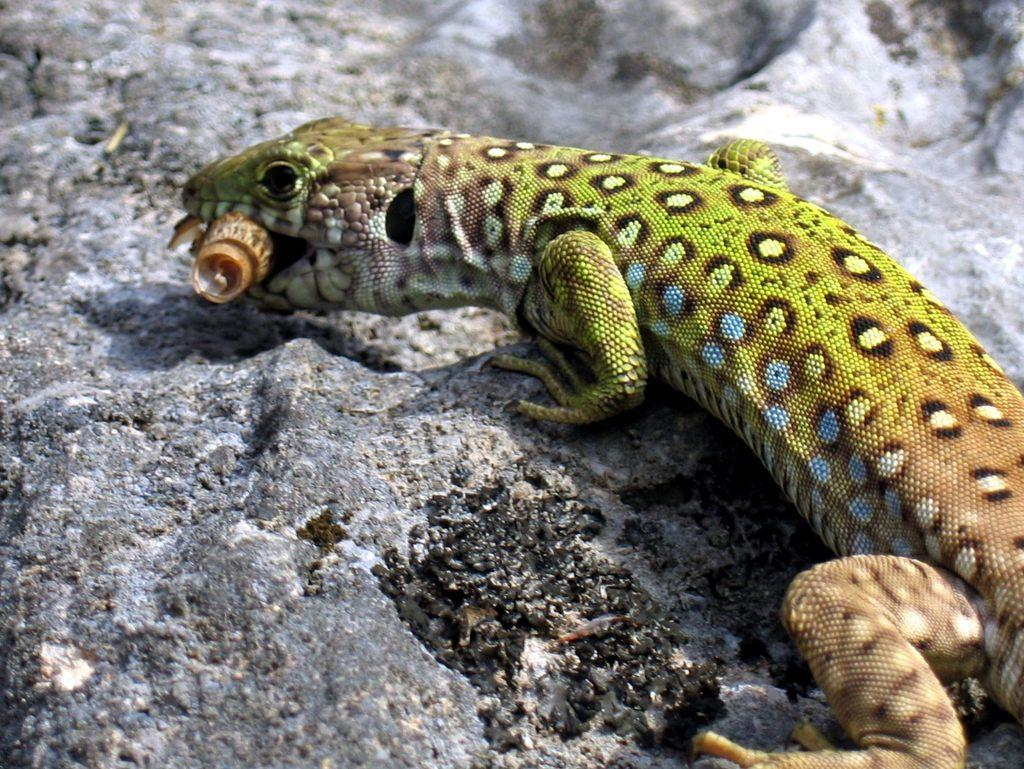What type of animal is in the image? There is a monitor lizard in the image. What color is the monitor lizard? The monitor lizard is green in color. What government policy is being discussed in the image? There is no discussion or reference to any government policy in the image, as it features a monitor lizard. What type of jelly is being served with the monitor lizard in the image? There is no jelly present in the image, as it features a monitor lizard. 